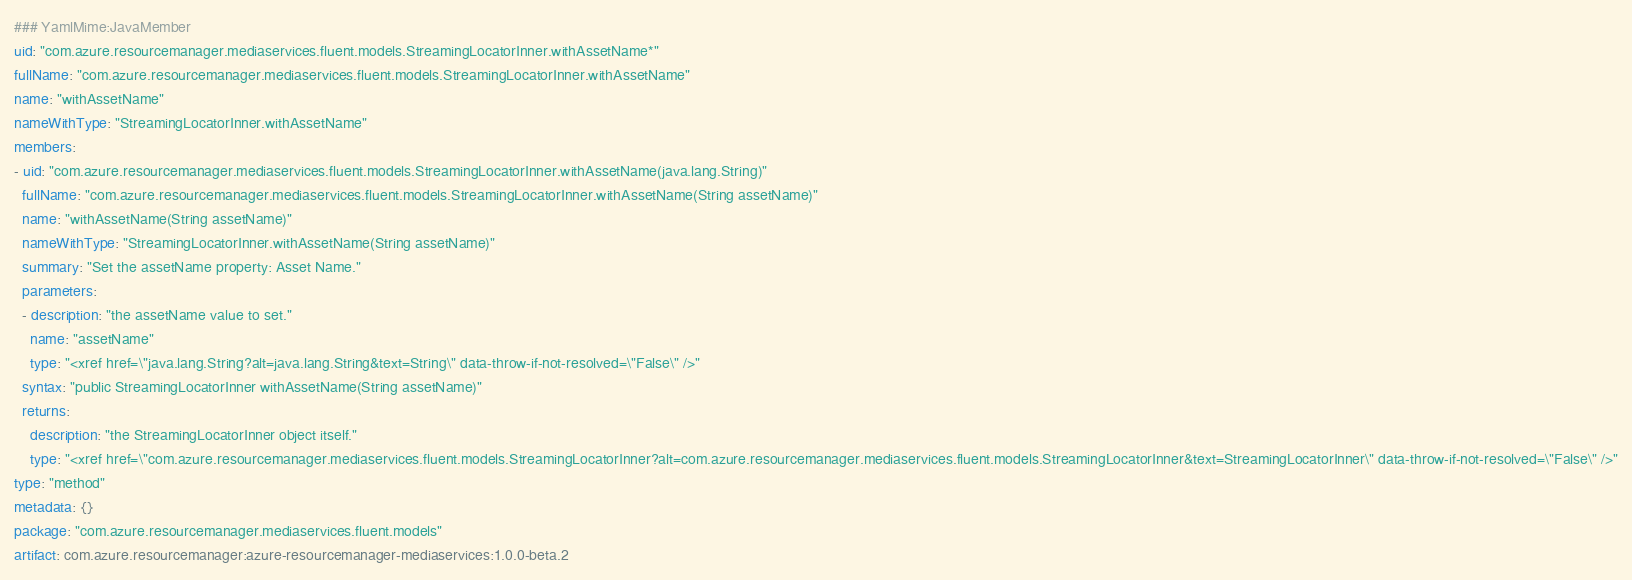Convert code to text. <code><loc_0><loc_0><loc_500><loc_500><_YAML_>### YamlMime:JavaMember
uid: "com.azure.resourcemanager.mediaservices.fluent.models.StreamingLocatorInner.withAssetName*"
fullName: "com.azure.resourcemanager.mediaservices.fluent.models.StreamingLocatorInner.withAssetName"
name: "withAssetName"
nameWithType: "StreamingLocatorInner.withAssetName"
members:
- uid: "com.azure.resourcemanager.mediaservices.fluent.models.StreamingLocatorInner.withAssetName(java.lang.String)"
  fullName: "com.azure.resourcemanager.mediaservices.fluent.models.StreamingLocatorInner.withAssetName(String assetName)"
  name: "withAssetName(String assetName)"
  nameWithType: "StreamingLocatorInner.withAssetName(String assetName)"
  summary: "Set the assetName property: Asset Name."
  parameters:
  - description: "the assetName value to set."
    name: "assetName"
    type: "<xref href=\"java.lang.String?alt=java.lang.String&text=String\" data-throw-if-not-resolved=\"False\" />"
  syntax: "public StreamingLocatorInner withAssetName(String assetName)"
  returns:
    description: "the StreamingLocatorInner object itself."
    type: "<xref href=\"com.azure.resourcemanager.mediaservices.fluent.models.StreamingLocatorInner?alt=com.azure.resourcemanager.mediaservices.fluent.models.StreamingLocatorInner&text=StreamingLocatorInner\" data-throw-if-not-resolved=\"False\" />"
type: "method"
metadata: {}
package: "com.azure.resourcemanager.mediaservices.fluent.models"
artifact: com.azure.resourcemanager:azure-resourcemanager-mediaservices:1.0.0-beta.2
</code> 